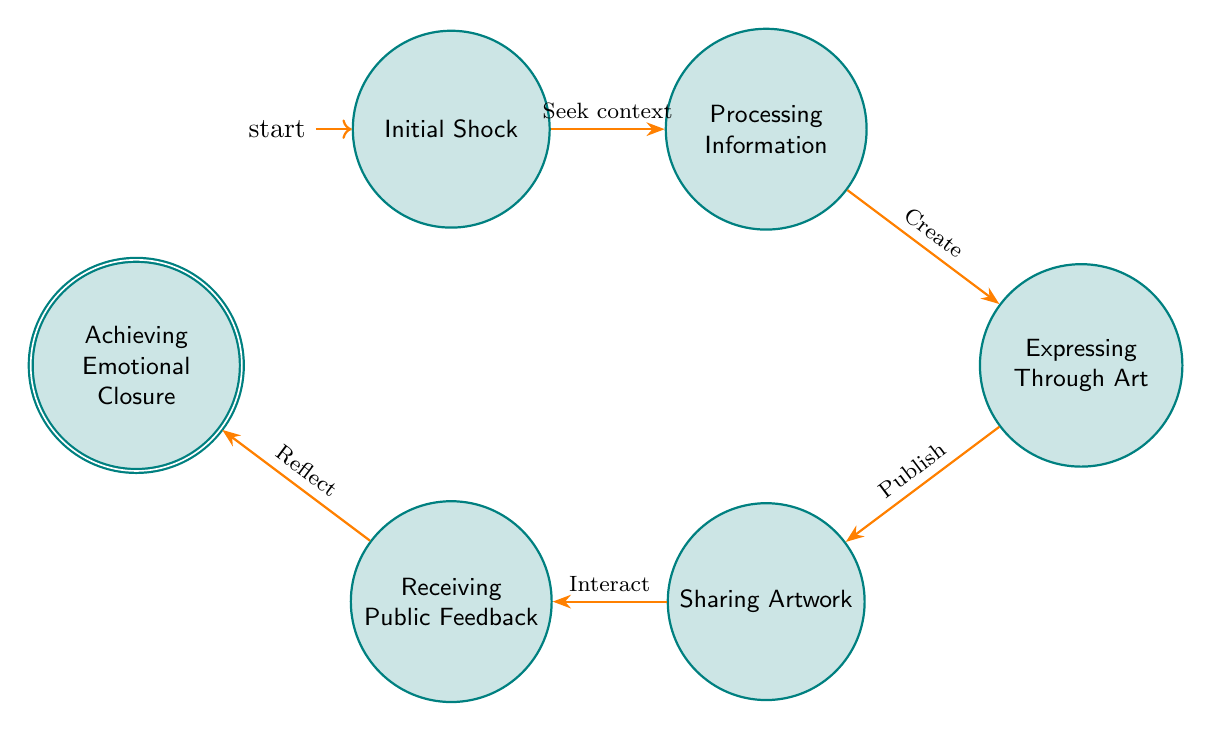What is the initial state in the diagram? The initial state is labeled as "Initial Shock," which represents the starting emotional response to a societal event.
Answer: Initial Shock How many states are present in the diagram? There are six distinct states identified in the diagram: Initial Shock, Processing Information, Expressing Through Art, Sharing Artwork, Receiving Public Feedback, and Achieving Emotional Closure.
Answer: Six From which state does the transition to "Expressing Through Art" occur? The transition to "Expressing Through Art" occurs from the state "Processing Information," indicating a flow from understanding to creative expression.
Answer: Processing Information What action leads from "Sharing Artwork" to "Receiving Public Feedback"? The action is "Interact," signifying that sharing the artwork prompts public interaction and feedback.
Answer: Interact Which state is the accepting state in the diagram? The accepting state is "Achieving Emotional Closure," representing the final phase where resolution is found.
Answer: Achieving Emotional Closure How many transitions occur in the diagram? There are five transitions in the diagram, representing the steps from one emotional state to another.
Answer: Five What is the relationship between "Processing Information" and "Initial Shock"? The relationship is that "Processing Information" follows after "Initial Shock," indicating a progression from a reaction to seeking understanding.
Answer: Processing Information follows Initial Shock What is the combined action to move from "Expressing Through Art" to "Sharing Artwork"? The combined action is "Publish," as it denotes the act of moving from creation to public sharing.
Answer: Publish Which state signifies the end of the emotional journey? The state that signifies the end of the emotional journey is "Achieving Emotional Closure," concluding the process of responding to societal events.
Answer: Achieving Emotional Closure 